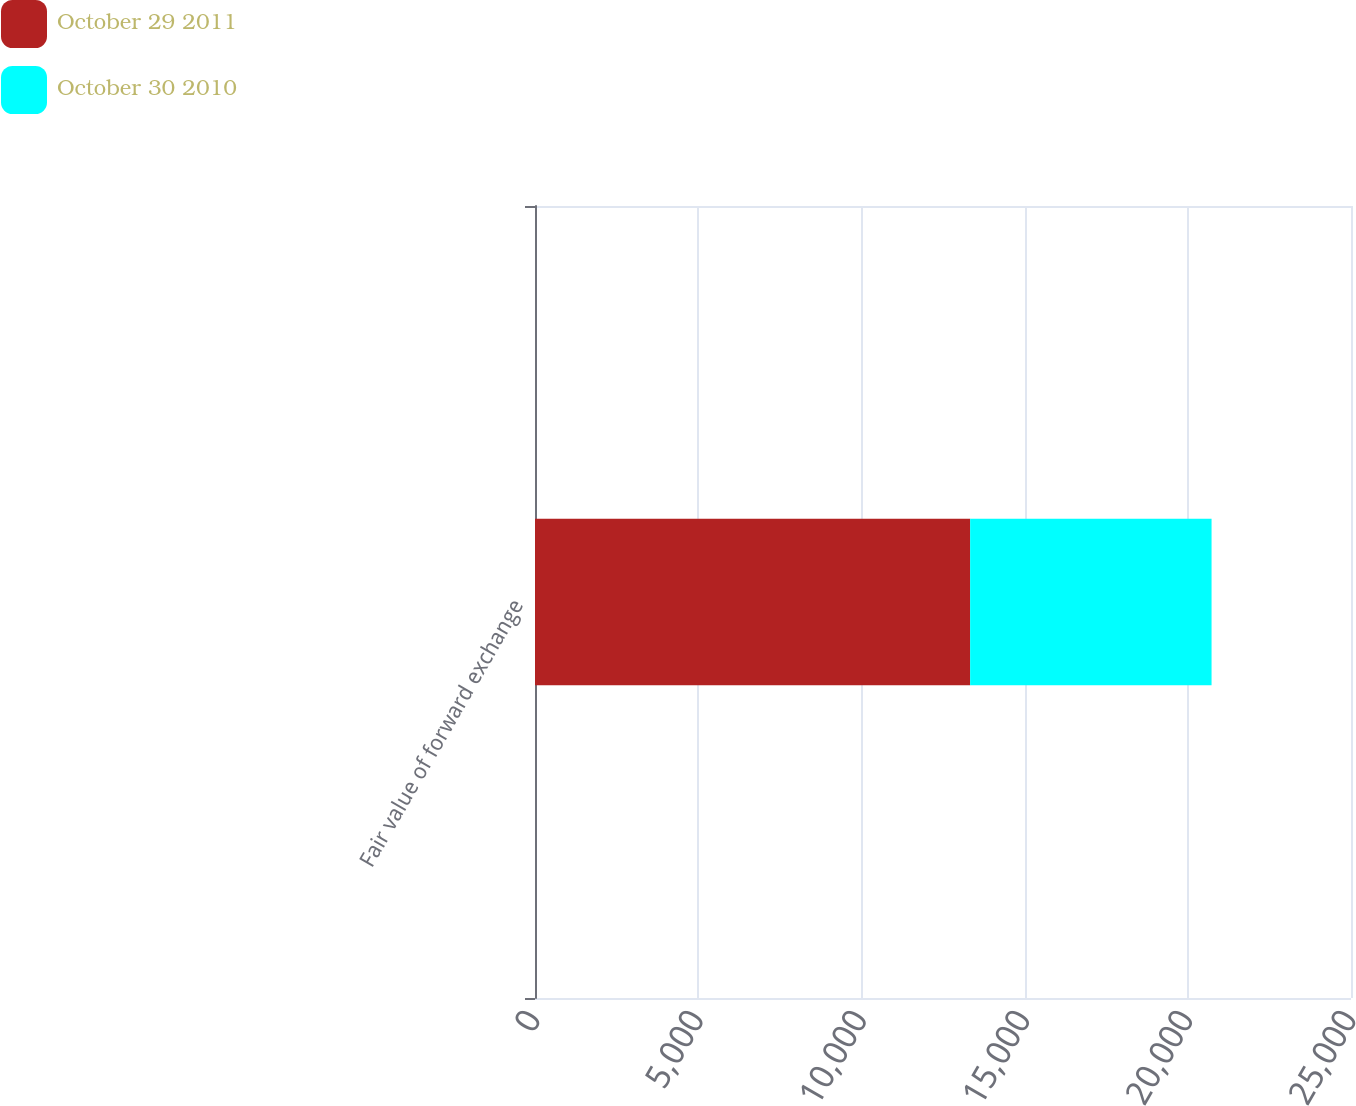Convert chart to OTSL. <chart><loc_0><loc_0><loc_500><loc_500><stacked_bar_chart><ecel><fcel>Fair value of forward exchange<nl><fcel>October 29 2011<fcel>13332<nl><fcel>October 30 2010<fcel>7396<nl></chart> 